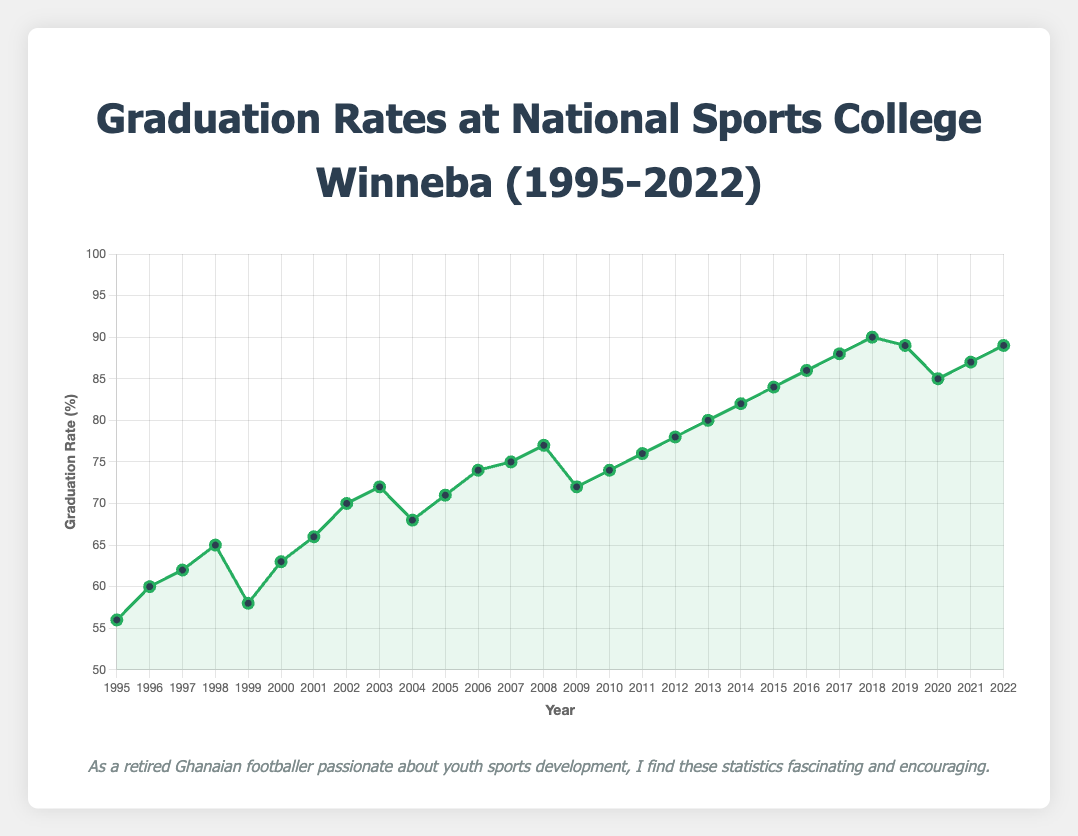What was the graduation rate in 2010? To find the graduation rate for a specific year, we look directly at the plotted point corresponding to 2010 on the x-axis. The y-axis shows the graduation rate. For 2010, the plotted point indicates a graduation rate of 74%.
Answer: 74% Which year had the lowest graduation rate? Scan the graph to identify the point that is the lowest on the y-axis. The year corresponding to this point on the x-axis is the year with the lowest graduation rate. The year 1995 has the lowest graduation rate at 56%.
Answer: 1995 Compare the graduation rates of 2000 and 2005. Which year had a higher rate? Locate the points for the years 2000 and 2005 on the x-axis. Compare their y-axis values. The graduation rate in 2000 is 63%, and in 2005 it is 71%. Therefore, 2005 had a higher graduation rate.
Answer: 2005 What is the difference in graduation rates between 2019 and 2020? Locate the points for the years 2019 and 2020 on the x-axis and note their y-axis values. The graduation rate in 2019 is 89%, and in 2020, it is 85%. Subtract the 2020 rate from the 2019 rate to get the difference: 89% - 85% = 4%.
Answer: 4% What is the average graduation rate from 2000 to 2010? Identify the graduation rates for each year from 2000 to 2010 and sum them: 63 + 66 + 70 + 72 + 68 + 71 + 74 + 75 + 77 + 72 + 74 = 782. Divide this sum by the number of years (11) to find the average: 782 / 11 ≈ 71.1%.
Answer: 71.1% Between which consecutive years did the graduation rate show the greatest increase? Examine the plot and determine the difference in graduation rates year over year. The largest increase is from 2004 (68%) to 2005 (71%), which is an increase of 3 percentage points. Double-check other consecutive year differences to confirm this is the greatest.
Answer: 2004-2005 By how much did the graduation rate change from 1995 to 2022? Locate the y-axis values for 1995 and 2022. The graduation rate in 1995 is 56%, and in 2022 it is 89%. Subtract the 1995 rate from the 2022 rate: 89% - 56% = 33%.
Answer: 33% What is the overall trend of the graduation rates from 1995 to 2022? Observe the general direction of the plotted line from 1995 to 2022. The trend appears to be upwards, indicating an overall increase in graduation rates.
Answer: Upwards During which five-year period did the graduation rate improve the most? Break down the timeline into five-year periods and calculate the change in graduation rates for each. The period with the most significant improvement is from 2014 (82%) to 2018 (90%), an increment of 8 percentage points.
Answer: 2014-2018 Which year(s) had a graduation rate of 74%? Identify the point(s) on the plot that align with the 74% graduation rate on the y-axis and note the corresponding years on the x-axis. The years with a 74% graduation rate are 2006 and 2010.
Answer: 2006, 2010 